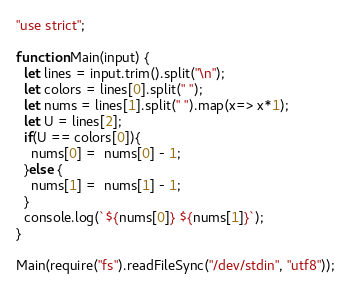<code> <loc_0><loc_0><loc_500><loc_500><_JavaScript_>"use strict";

function Main(input) {
  let lines = input.trim().split("\n");
  let colors = lines[0].split(" ");
  let nums = lines[1].split(" ").map(x=> x*1);
  let U = lines[2];
  if(U == colors[0]){
  	nums[0] =  nums[0] - 1;
  }else {
    nums[1] =  nums[1] - 1;
  }
  console.log(`${nums[0]} ${nums[1]}`);
}

Main(require("fs").readFileSync("/dev/stdin", "utf8"));

</code> 